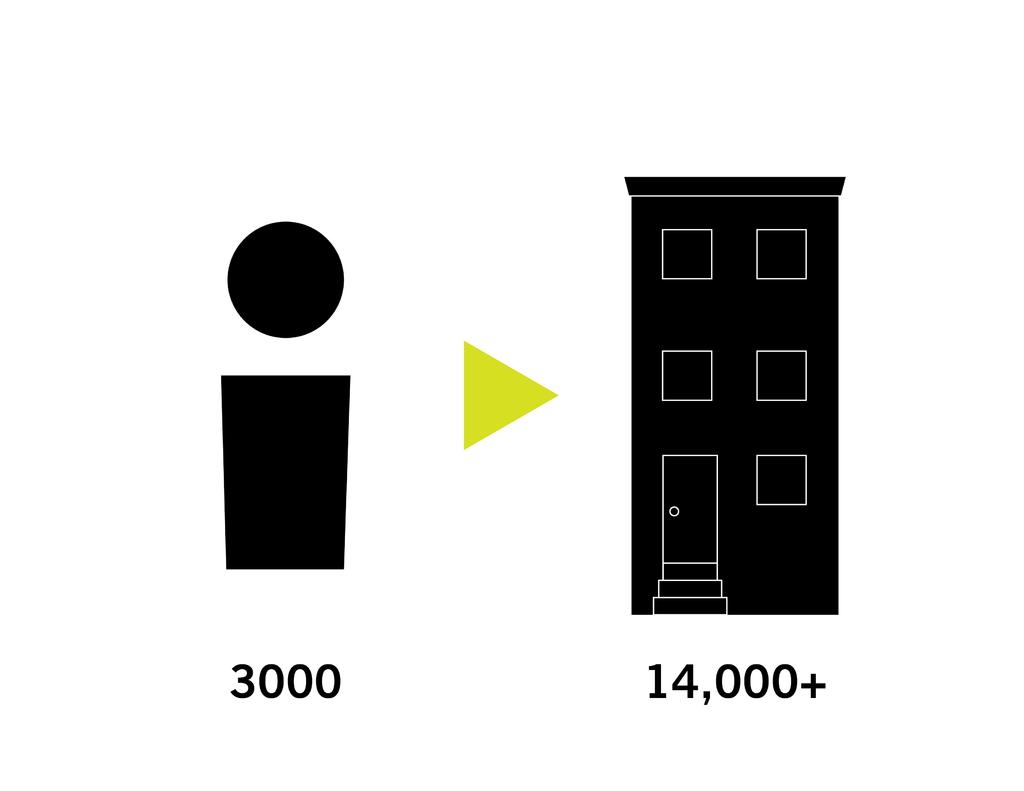<image>
Provide a brief description of the given image. A figure of a body with 3000 under it with an arrow towards a building with 14,000+ under it. 